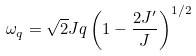<formula> <loc_0><loc_0><loc_500><loc_500>\omega _ { q } = \sqrt { 2 } J q \left ( 1 - \frac { 2 J ^ { \prime } } { J } \right ) ^ { 1 / 2 }</formula> 